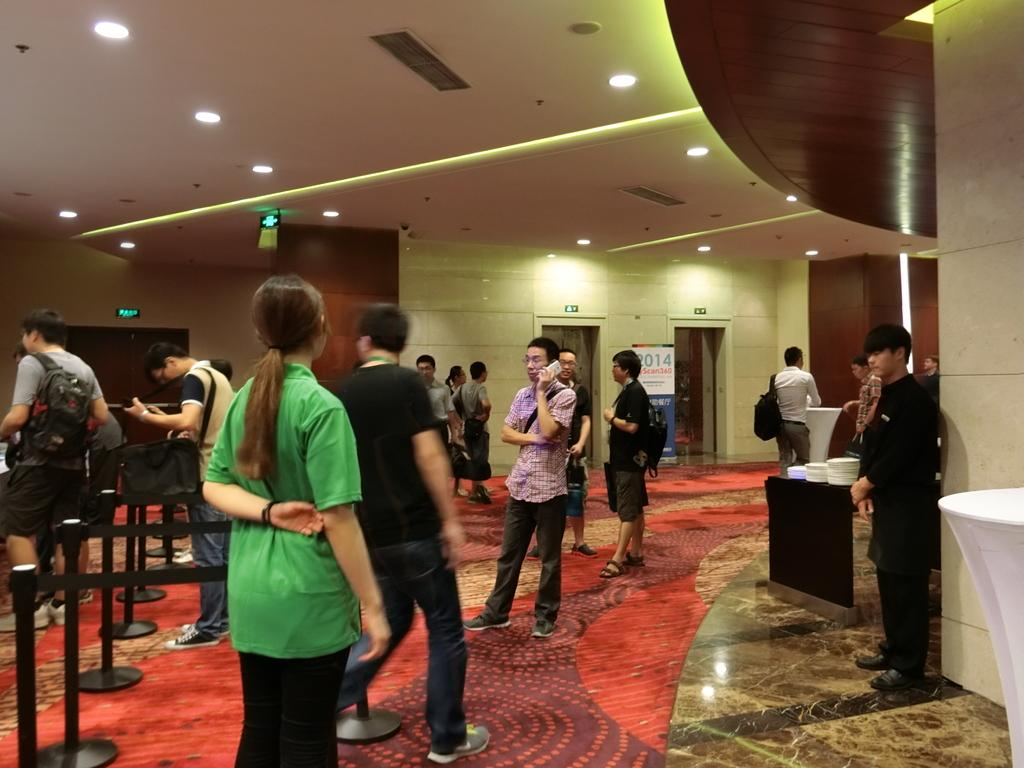What type of structure can be seen in the image? There is a wall in the image. Are there any openings in the wall? Yes, there are doors in the image. What is hanging on the wall? There is a banner in the image. Who or what is present in the image? There are people standing in the image. What type of illumination is present in the image? There are lights in the image. What is on the table in the image? There is a table in the image with plates on it. What scientific discovery is being celebrated with the banner in the image? There is no indication of a scientific discovery being celebrated in the image; the banner's purpose is not mentioned. What message of peace is being conveyed by the people standing in the image? There is no mention of peace or any specific message being conveyed by the people standing in the image. 